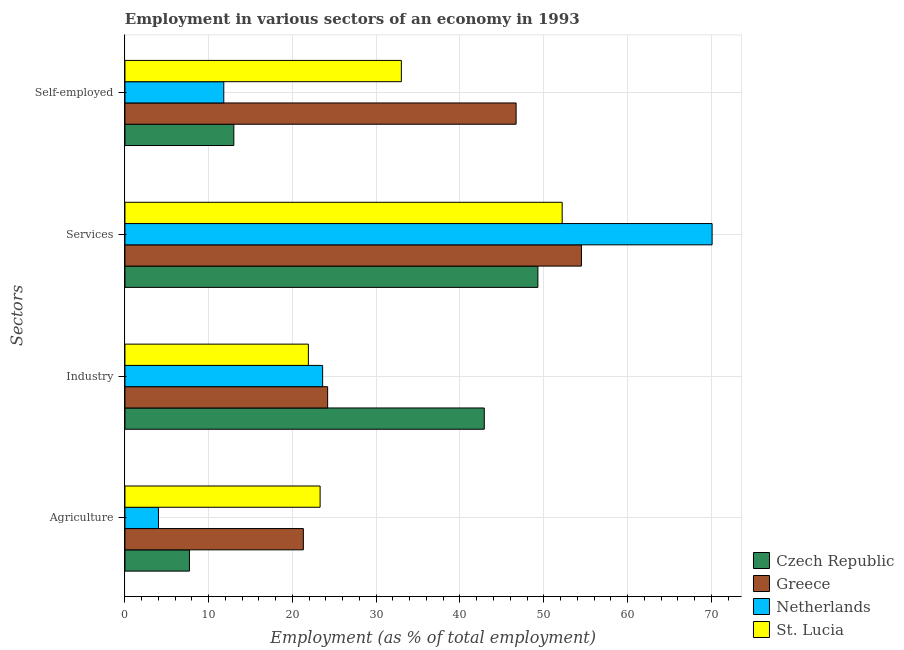What is the label of the 1st group of bars from the top?
Give a very brief answer. Self-employed. What is the percentage of workers in services in Netherlands?
Keep it short and to the point. 70.1. Across all countries, what is the maximum percentage of self employed workers?
Provide a succinct answer. 46.7. Across all countries, what is the minimum percentage of workers in services?
Your answer should be compact. 49.3. In which country was the percentage of self employed workers maximum?
Your answer should be compact. Greece. In which country was the percentage of workers in services minimum?
Keep it short and to the point. Czech Republic. What is the total percentage of workers in services in the graph?
Give a very brief answer. 226.1. What is the difference between the percentage of workers in agriculture in Czech Republic and that in St. Lucia?
Your answer should be compact. -15.6. What is the difference between the percentage of workers in services in Greece and the percentage of workers in industry in St. Lucia?
Ensure brevity in your answer.  32.6. What is the average percentage of self employed workers per country?
Give a very brief answer. 26.13. What is the difference between the percentage of workers in industry and percentage of workers in services in Czech Republic?
Make the answer very short. -6.4. What is the ratio of the percentage of self employed workers in St. Lucia to that in Netherlands?
Your answer should be very brief. 2.8. Is the percentage of self employed workers in St. Lucia less than that in Czech Republic?
Keep it short and to the point. No. Is the difference between the percentage of workers in services in St. Lucia and Czech Republic greater than the difference between the percentage of workers in industry in St. Lucia and Czech Republic?
Your response must be concise. Yes. What is the difference between the highest and the second highest percentage of self employed workers?
Make the answer very short. 13.7. What is the difference between the highest and the lowest percentage of workers in services?
Provide a short and direct response. 20.8. Is the sum of the percentage of workers in agriculture in Netherlands and St. Lucia greater than the maximum percentage of workers in industry across all countries?
Provide a succinct answer. No. What does the 1st bar from the top in Industry represents?
Make the answer very short. St. Lucia. What does the 4th bar from the bottom in Industry represents?
Offer a very short reply. St. Lucia. Is it the case that in every country, the sum of the percentage of workers in agriculture and percentage of workers in industry is greater than the percentage of workers in services?
Offer a very short reply. No. How many bars are there?
Your answer should be very brief. 16. Are all the bars in the graph horizontal?
Your response must be concise. Yes. How many countries are there in the graph?
Offer a very short reply. 4. Are the values on the major ticks of X-axis written in scientific E-notation?
Give a very brief answer. No. What is the title of the graph?
Provide a short and direct response. Employment in various sectors of an economy in 1993. What is the label or title of the X-axis?
Offer a terse response. Employment (as % of total employment). What is the label or title of the Y-axis?
Make the answer very short. Sectors. What is the Employment (as % of total employment) in Czech Republic in Agriculture?
Give a very brief answer. 7.7. What is the Employment (as % of total employment) of Greece in Agriculture?
Your response must be concise. 21.3. What is the Employment (as % of total employment) of Netherlands in Agriculture?
Provide a succinct answer. 4. What is the Employment (as % of total employment) of St. Lucia in Agriculture?
Your response must be concise. 23.3. What is the Employment (as % of total employment) in Czech Republic in Industry?
Make the answer very short. 42.9. What is the Employment (as % of total employment) in Greece in Industry?
Keep it short and to the point. 24.2. What is the Employment (as % of total employment) of Netherlands in Industry?
Your answer should be compact. 23.6. What is the Employment (as % of total employment) in St. Lucia in Industry?
Your response must be concise. 21.9. What is the Employment (as % of total employment) of Czech Republic in Services?
Provide a short and direct response. 49.3. What is the Employment (as % of total employment) in Greece in Services?
Your answer should be compact. 54.5. What is the Employment (as % of total employment) in Netherlands in Services?
Provide a short and direct response. 70.1. What is the Employment (as % of total employment) in St. Lucia in Services?
Offer a very short reply. 52.2. What is the Employment (as % of total employment) in Czech Republic in Self-employed?
Ensure brevity in your answer.  13. What is the Employment (as % of total employment) in Greece in Self-employed?
Offer a terse response. 46.7. What is the Employment (as % of total employment) in Netherlands in Self-employed?
Provide a short and direct response. 11.8. Across all Sectors, what is the maximum Employment (as % of total employment) of Czech Republic?
Ensure brevity in your answer.  49.3. Across all Sectors, what is the maximum Employment (as % of total employment) of Greece?
Your answer should be compact. 54.5. Across all Sectors, what is the maximum Employment (as % of total employment) in Netherlands?
Provide a succinct answer. 70.1. Across all Sectors, what is the maximum Employment (as % of total employment) in St. Lucia?
Provide a short and direct response. 52.2. Across all Sectors, what is the minimum Employment (as % of total employment) of Czech Republic?
Offer a very short reply. 7.7. Across all Sectors, what is the minimum Employment (as % of total employment) in Greece?
Offer a very short reply. 21.3. Across all Sectors, what is the minimum Employment (as % of total employment) of St. Lucia?
Offer a terse response. 21.9. What is the total Employment (as % of total employment) in Czech Republic in the graph?
Make the answer very short. 112.9. What is the total Employment (as % of total employment) of Greece in the graph?
Your response must be concise. 146.7. What is the total Employment (as % of total employment) in Netherlands in the graph?
Offer a very short reply. 109.5. What is the total Employment (as % of total employment) in St. Lucia in the graph?
Your answer should be compact. 130.4. What is the difference between the Employment (as % of total employment) of Czech Republic in Agriculture and that in Industry?
Offer a very short reply. -35.2. What is the difference between the Employment (as % of total employment) in Netherlands in Agriculture and that in Industry?
Offer a very short reply. -19.6. What is the difference between the Employment (as % of total employment) of St. Lucia in Agriculture and that in Industry?
Provide a succinct answer. 1.4. What is the difference between the Employment (as % of total employment) of Czech Republic in Agriculture and that in Services?
Offer a terse response. -41.6. What is the difference between the Employment (as % of total employment) of Greece in Agriculture and that in Services?
Your response must be concise. -33.2. What is the difference between the Employment (as % of total employment) of Netherlands in Agriculture and that in Services?
Your response must be concise. -66.1. What is the difference between the Employment (as % of total employment) of St. Lucia in Agriculture and that in Services?
Provide a short and direct response. -28.9. What is the difference between the Employment (as % of total employment) in Greece in Agriculture and that in Self-employed?
Give a very brief answer. -25.4. What is the difference between the Employment (as % of total employment) in Netherlands in Agriculture and that in Self-employed?
Provide a short and direct response. -7.8. What is the difference between the Employment (as % of total employment) of St. Lucia in Agriculture and that in Self-employed?
Your response must be concise. -9.7. What is the difference between the Employment (as % of total employment) in Greece in Industry and that in Services?
Ensure brevity in your answer.  -30.3. What is the difference between the Employment (as % of total employment) of Netherlands in Industry and that in Services?
Your answer should be very brief. -46.5. What is the difference between the Employment (as % of total employment) of St. Lucia in Industry and that in Services?
Your answer should be compact. -30.3. What is the difference between the Employment (as % of total employment) in Czech Republic in Industry and that in Self-employed?
Offer a terse response. 29.9. What is the difference between the Employment (as % of total employment) in Greece in Industry and that in Self-employed?
Make the answer very short. -22.5. What is the difference between the Employment (as % of total employment) of Czech Republic in Services and that in Self-employed?
Make the answer very short. 36.3. What is the difference between the Employment (as % of total employment) of Netherlands in Services and that in Self-employed?
Make the answer very short. 58.3. What is the difference between the Employment (as % of total employment) in Czech Republic in Agriculture and the Employment (as % of total employment) in Greece in Industry?
Offer a very short reply. -16.5. What is the difference between the Employment (as % of total employment) of Czech Republic in Agriculture and the Employment (as % of total employment) of Netherlands in Industry?
Give a very brief answer. -15.9. What is the difference between the Employment (as % of total employment) of Greece in Agriculture and the Employment (as % of total employment) of St. Lucia in Industry?
Offer a terse response. -0.6. What is the difference between the Employment (as % of total employment) in Netherlands in Agriculture and the Employment (as % of total employment) in St. Lucia in Industry?
Make the answer very short. -17.9. What is the difference between the Employment (as % of total employment) of Czech Republic in Agriculture and the Employment (as % of total employment) of Greece in Services?
Give a very brief answer. -46.8. What is the difference between the Employment (as % of total employment) of Czech Republic in Agriculture and the Employment (as % of total employment) of Netherlands in Services?
Your response must be concise. -62.4. What is the difference between the Employment (as % of total employment) of Czech Republic in Agriculture and the Employment (as % of total employment) of St. Lucia in Services?
Offer a very short reply. -44.5. What is the difference between the Employment (as % of total employment) of Greece in Agriculture and the Employment (as % of total employment) of Netherlands in Services?
Offer a very short reply. -48.8. What is the difference between the Employment (as % of total employment) in Greece in Agriculture and the Employment (as % of total employment) in St. Lucia in Services?
Provide a short and direct response. -30.9. What is the difference between the Employment (as % of total employment) of Netherlands in Agriculture and the Employment (as % of total employment) of St. Lucia in Services?
Your answer should be very brief. -48.2. What is the difference between the Employment (as % of total employment) of Czech Republic in Agriculture and the Employment (as % of total employment) of Greece in Self-employed?
Your answer should be compact. -39. What is the difference between the Employment (as % of total employment) in Czech Republic in Agriculture and the Employment (as % of total employment) in Netherlands in Self-employed?
Give a very brief answer. -4.1. What is the difference between the Employment (as % of total employment) of Czech Republic in Agriculture and the Employment (as % of total employment) of St. Lucia in Self-employed?
Give a very brief answer. -25.3. What is the difference between the Employment (as % of total employment) in Greece in Agriculture and the Employment (as % of total employment) in St. Lucia in Self-employed?
Keep it short and to the point. -11.7. What is the difference between the Employment (as % of total employment) of Netherlands in Agriculture and the Employment (as % of total employment) of St. Lucia in Self-employed?
Provide a succinct answer. -29. What is the difference between the Employment (as % of total employment) in Czech Republic in Industry and the Employment (as % of total employment) in Netherlands in Services?
Provide a short and direct response. -27.2. What is the difference between the Employment (as % of total employment) of Czech Republic in Industry and the Employment (as % of total employment) of St. Lucia in Services?
Your answer should be very brief. -9.3. What is the difference between the Employment (as % of total employment) in Greece in Industry and the Employment (as % of total employment) in Netherlands in Services?
Keep it short and to the point. -45.9. What is the difference between the Employment (as % of total employment) of Greece in Industry and the Employment (as % of total employment) of St. Lucia in Services?
Offer a very short reply. -28. What is the difference between the Employment (as % of total employment) of Netherlands in Industry and the Employment (as % of total employment) of St. Lucia in Services?
Offer a very short reply. -28.6. What is the difference between the Employment (as % of total employment) of Czech Republic in Industry and the Employment (as % of total employment) of Greece in Self-employed?
Your answer should be very brief. -3.8. What is the difference between the Employment (as % of total employment) in Czech Republic in Industry and the Employment (as % of total employment) in Netherlands in Self-employed?
Provide a short and direct response. 31.1. What is the difference between the Employment (as % of total employment) in Czech Republic in Industry and the Employment (as % of total employment) in St. Lucia in Self-employed?
Offer a terse response. 9.9. What is the difference between the Employment (as % of total employment) in Greece in Industry and the Employment (as % of total employment) in Netherlands in Self-employed?
Offer a very short reply. 12.4. What is the difference between the Employment (as % of total employment) in Czech Republic in Services and the Employment (as % of total employment) in Greece in Self-employed?
Offer a terse response. 2.6. What is the difference between the Employment (as % of total employment) of Czech Republic in Services and the Employment (as % of total employment) of Netherlands in Self-employed?
Your answer should be compact. 37.5. What is the difference between the Employment (as % of total employment) in Greece in Services and the Employment (as % of total employment) in Netherlands in Self-employed?
Your response must be concise. 42.7. What is the difference between the Employment (as % of total employment) in Netherlands in Services and the Employment (as % of total employment) in St. Lucia in Self-employed?
Provide a short and direct response. 37.1. What is the average Employment (as % of total employment) of Czech Republic per Sectors?
Your answer should be compact. 28.23. What is the average Employment (as % of total employment) in Greece per Sectors?
Your answer should be very brief. 36.67. What is the average Employment (as % of total employment) in Netherlands per Sectors?
Give a very brief answer. 27.38. What is the average Employment (as % of total employment) in St. Lucia per Sectors?
Provide a short and direct response. 32.6. What is the difference between the Employment (as % of total employment) in Czech Republic and Employment (as % of total employment) in St. Lucia in Agriculture?
Offer a very short reply. -15.6. What is the difference between the Employment (as % of total employment) of Greece and Employment (as % of total employment) of Netherlands in Agriculture?
Your answer should be very brief. 17.3. What is the difference between the Employment (as % of total employment) of Netherlands and Employment (as % of total employment) of St. Lucia in Agriculture?
Make the answer very short. -19.3. What is the difference between the Employment (as % of total employment) in Czech Republic and Employment (as % of total employment) in Greece in Industry?
Keep it short and to the point. 18.7. What is the difference between the Employment (as % of total employment) in Czech Republic and Employment (as % of total employment) in Netherlands in Industry?
Provide a succinct answer. 19.3. What is the difference between the Employment (as % of total employment) in Greece and Employment (as % of total employment) in St. Lucia in Industry?
Your response must be concise. 2.3. What is the difference between the Employment (as % of total employment) in Netherlands and Employment (as % of total employment) in St. Lucia in Industry?
Keep it short and to the point. 1.7. What is the difference between the Employment (as % of total employment) in Czech Republic and Employment (as % of total employment) in Greece in Services?
Ensure brevity in your answer.  -5.2. What is the difference between the Employment (as % of total employment) in Czech Republic and Employment (as % of total employment) in Netherlands in Services?
Your answer should be very brief. -20.8. What is the difference between the Employment (as % of total employment) of Greece and Employment (as % of total employment) of Netherlands in Services?
Provide a short and direct response. -15.6. What is the difference between the Employment (as % of total employment) of Greece and Employment (as % of total employment) of St. Lucia in Services?
Offer a very short reply. 2.3. What is the difference between the Employment (as % of total employment) of Czech Republic and Employment (as % of total employment) of Greece in Self-employed?
Keep it short and to the point. -33.7. What is the difference between the Employment (as % of total employment) in Czech Republic and Employment (as % of total employment) in Netherlands in Self-employed?
Offer a terse response. 1.2. What is the difference between the Employment (as % of total employment) of Greece and Employment (as % of total employment) of Netherlands in Self-employed?
Make the answer very short. 34.9. What is the difference between the Employment (as % of total employment) in Greece and Employment (as % of total employment) in St. Lucia in Self-employed?
Provide a short and direct response. 13.7. What is the difference between the Employment (as % of total employment) in Netherlands and Employment (as % of total employment) in St. Lucia in Self-employed?
Your answer should be very brief. -21.2. What is the ratio of the Employment (as % of total employment) in Czech Republic in Agriculture to that in Industry?
Make the answer very short. 0.18. What is the ratio of the Employment (as % of total employment) in Greece in Agriculture to that in Industry?
Provide a succinct answer. 0.88. What is the ratio of the Employment (as % of total employment) of Netherlands in Agriculture to that in Industry?
Your answer should be compact. 0.17. What is the ratio of the Employment (as % of total employment) in St. Lucia in Agriculture to that in Industry?
Your response must be concise. 1.06. What is the ratio of the Employment (as % of total employment) of Czech Republic in Agriculture to that in Services?
Your answer should be compact. 0.16. What is the ratio of the Employment (as % of total employment) in Greece in Agriculture to that in Services?
Your answer should be very brief. 0.39. What is the ratio of the Employment (as % of total employment) of Netherlands in Agriculture to that in Services?
Your answer should be compact. 0.06. What is the ratio of the Employment (as % of total employment) of St. Lucia in Agriculture to that in Services?
Provide a short and direct response. 0.45. What is the ratio of the Employment (as % of total employment) of Czech Republic in Agriculture to that in Self-employed?
Give a very brief answer. 0.59. What is the ratio of the Employment (as % of total employment) in Greece in Agriculture to that in Self-employed?
Your answer should be compact. 0.46. What is the ratio of the Employment (as % of total employment) in Netherlands in Agriculture to that in Self-employed?
Offer a terse response. 0.34. What is the ratio of the Employment (as % of total employment) in St. Lucia in Agriculture to that in Self-employed?
Your answer should be compact. 0.71. What is the ratio of the Employment (as % of total employment) in Czech Republic in Industry to that in Services?
Make the answer very short. 0.87. What is the ratio of the Employment (as % of total employment) of Greece in Industry to that in Services?
Your answer should be compact. 0.44. What is the ratio of the Employment (as % of total employment) in Netherlands in Industry to that in Services?
Offer a terse response. 0.34. What is the ratio of the Employment (as % of total employment) in St. Lucia in Industry to that in Services?
Offer a very short reply. 0.42. What is the ratio of the Employment (as % of total employment) in Greece in Industry to that in Self-employed?
Provide a short and direct response. 0.52. What is the ratio of the Employment (as % of total employment) of St. Lucia in Industry to that in Self-employed?
Keep it short and to the point. 0.66. What is the ratio of the Employment (as % of total employment) in Czech Republic in Services to that in Self-employed?
Keep it short and to the point. 3.79. What is the ratio of the Employment (as % of total employment) in Greece in Services to that in Self-employed?
Your answer should be very brief. 1.17. What is the ratio of the Employment (as % of total employment) in Netherlands in Services to that in Self-employed?
Provide a short and direct response. 5.94. What is the ratio of the Employment (as % of total employment) in St. Lucia in Services to that in Self-employed?
Provide a succinct answer. 1.58. What is the difference between the highest and the second highest Employment (as % of total employment) in Netherlands?
Offer a very short reply. 46.5. What is the difference between the highest and the lowest Employment (as % of total employment) in Czech Republic?
Give a very brief answer. 41.6. What is the difference between the highest and the lowest Employment (as % of total employment) of Greece?
Your response must be concise. 33.2. What is the difference between the highest and the lowest Employment (as % of total employment) of Netherlands?
Offer a terse response. 66.1. What is the difference between the highest and the lowest Employment (as % of total employment) in St. Lucia?
Provide a short and direct response. 30.3. 